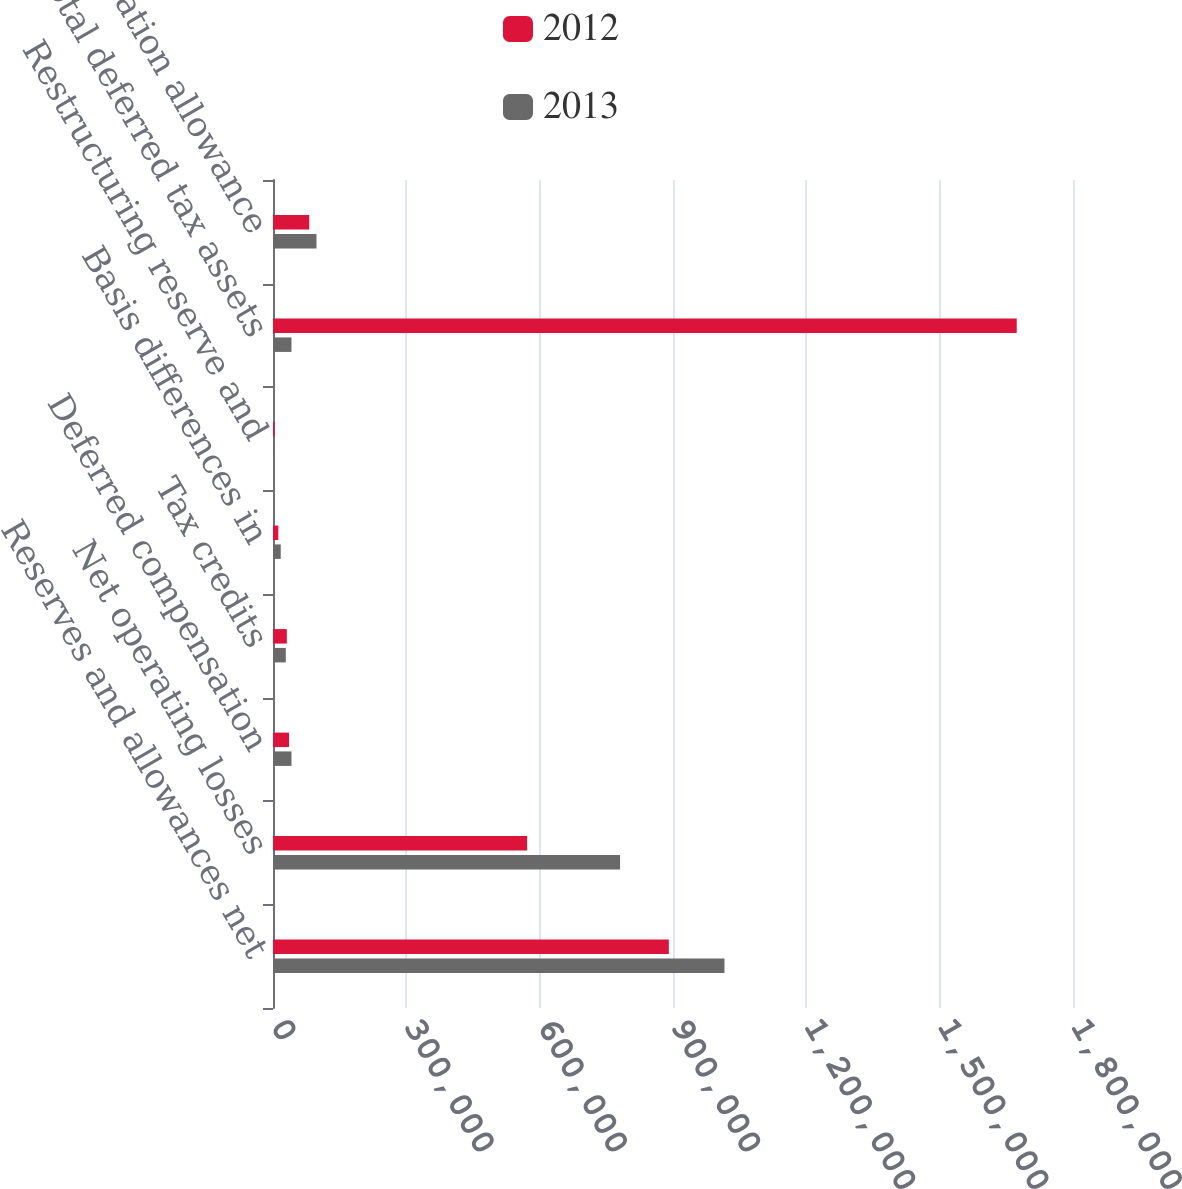Convert chart to OTSL. <chart><loc_0><loc_0><loc_500><loc_500><stacked_bar_chart><ecel><fcel>Reserves and allowances net<fcel>Net operating losses<fcel>Deferred compensation<fcel>Tax credits<fcel>Basis differences in<fcel>Restructuring reserve and<fcel>Total deferred tax assets<fcel>Valuation allowance<nl><fcel>2012<fcel>890648<fcel>571793<fcel>36093<fcel>31120<fcel>11984<fcel>3736<fcel>1.67342e+06<fcel>81543<nl><fcel>2013<fcel>1.0158e+06<fcel>780883<fcel>41572<fcel>28775<fcel>17417<fcel>2162<fcel>41572<fcel>97837<nl></chart> 